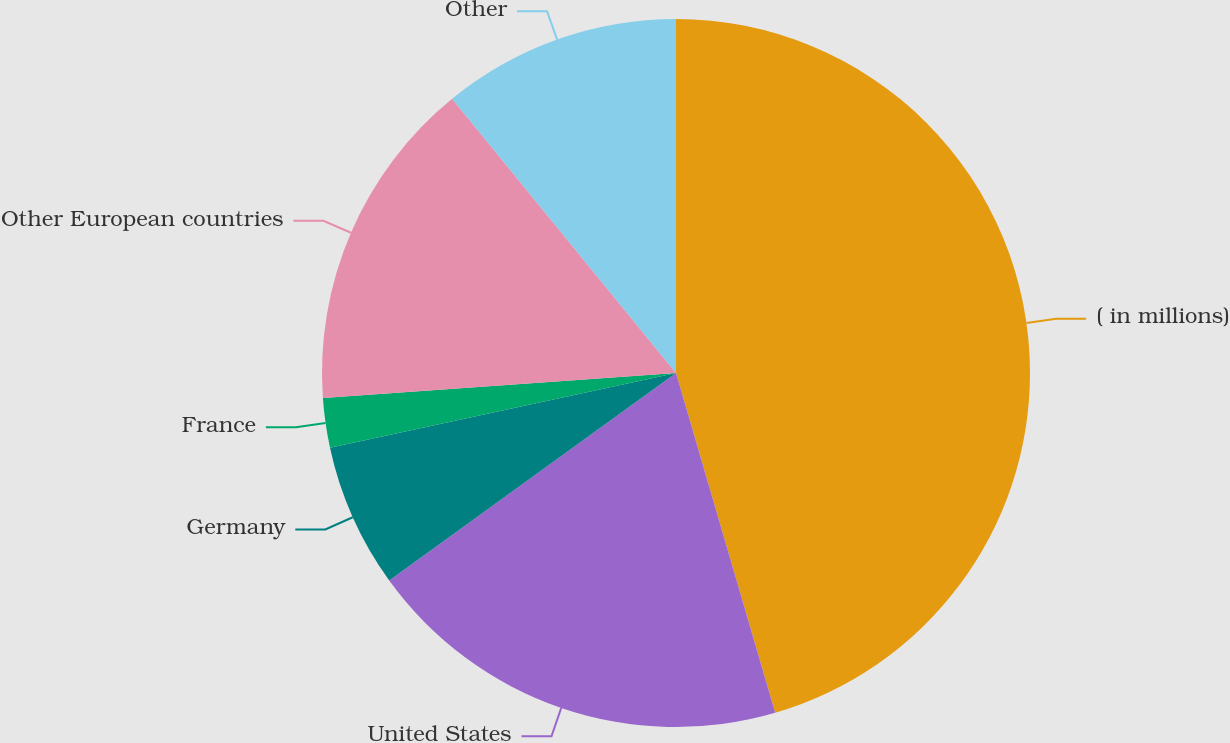<chart> <loc_0><loc_0><loc_500><loc_500><pie_chart><fcel>( in millions)<fcel>United States<fcel>Germany<fcel>France<fcel>Other European countries<fcel>Other<nl><fcel>45.48%<fcel>19.55%<fcel>6.58%<fcel>2.26%<fcel>15.23%<fcel>10.9%<nl></chart> 